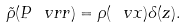Convert formula to latex. <formula><loc_0><loc_0><loc_500><loc_500>\tilde { \rho } ( P \ v r r ) = \rho ( \ v x ) \delta ( z ) .</formula> 